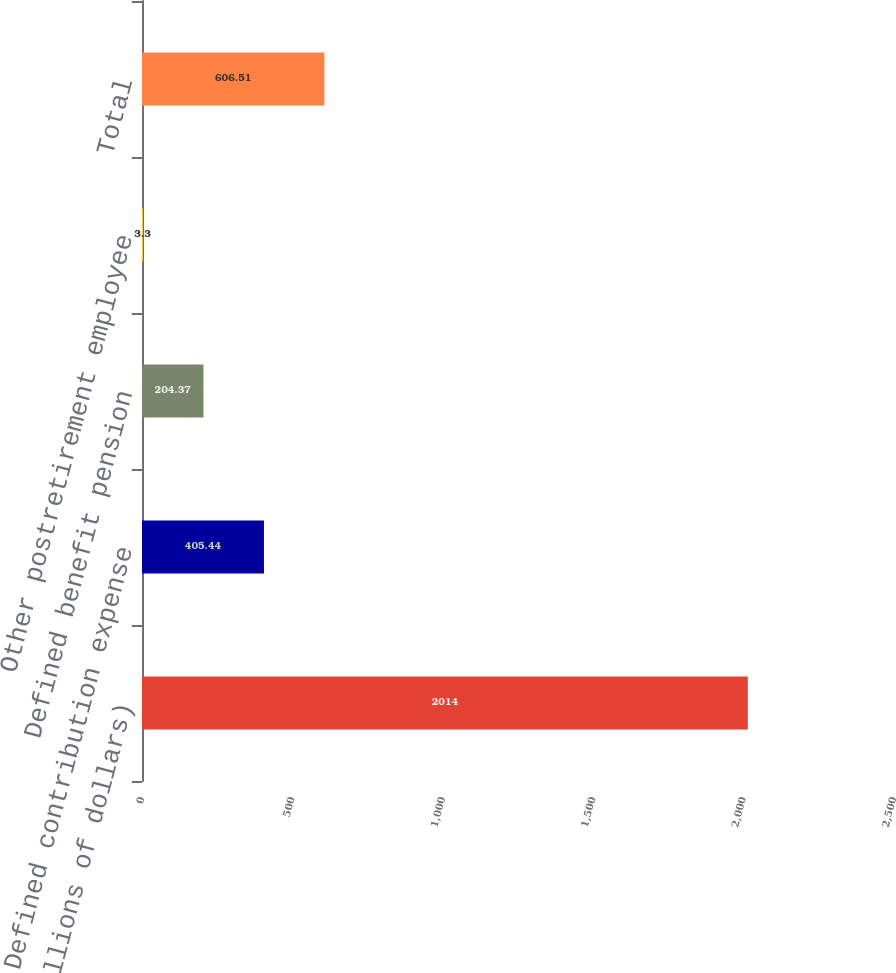Convert chart to OTSL. <chart><loc_0><loc_0><loc_500><loc_500><bar_chart><fcel>(millions of dollars)<fcel>Defined contribution expense<fcel>Defined benefit pension<fcel>Other postretirement employee<fcel>Total<nl><fcel>2014<fcel>405.44<fcel>204.37<fcel>3.3<fcel>606.51<nl></chart> 